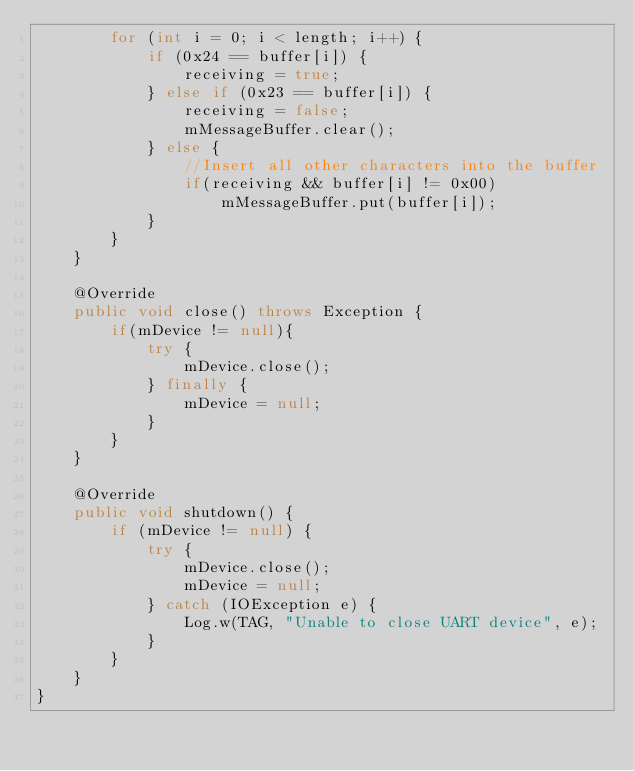Convert code to text. <code><loc_0><loc_0><loc_500><loc_500><_Java_>        for (int i = 0; i < length; i++) {
            if (0x24 == buffer[i]) {
                receiving = true;
            } else if (0x23 == buffer[i]) {
                receiving = false;
                mMessageBuffer.clear();
            } else {
                //Insert all other characters into the buffer
                if(receiving && buffer[i] != 0x00)
                    mMessageBuffer.put(buffer[i]);
            }
        }
    }

    @Override
    public void close() throws Exception {
        if(mDevice != null){
            try {
                mDevice.close();
            } finally {
                mDevice = null;
            }
        }
    }

    @Override
    public void shutdown() {
        if (mDevice != null) {
            try {
                mDevice.close();
                mDevice = null;
            } catch (IOException e) {
                Log.w(TAG, "Unable to close UART device", e);
            }
        }
    }
}
</code> 